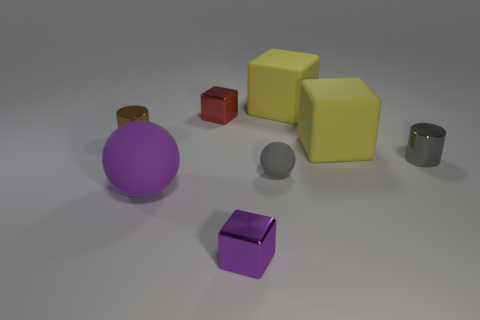What is the small object that is on the right side of the purple shiny block and on the left side of the gray shiny thing made of?
Give a very brief answer. Rubber. What number of matte objects are either tiny cubes or yellow cylinders?
Keep it short and to the point. 0. What is the shape of the purple object that is the same material as the red thing?
Provide a succinct answer. Cube. What number of objects are on the left side of the purple matte thing and behind the red metallic block?
Provide a succinct answer. 0. Are there any other things that are the same shape as the small purple metal thing?
Provide a short and direct response. Yes. What is the size of the object that is left of the purple ball?
Your answer should be very brief. Small. How many other things are there of the same color as the tiny rubber object?
Provide a short and direct response. 1. There is a cylinder to the left of the yellow rubber cube behind the small red block; what is it made of?
Offer a terse response. Metal. Is the color of the cylinder on the right side of the gray rubber thing the same as the tiny ball?
Your response must be concise. Yes. What number of other gray things have the same shape as the gray rubber object?
Your answer should be compact. 0. 